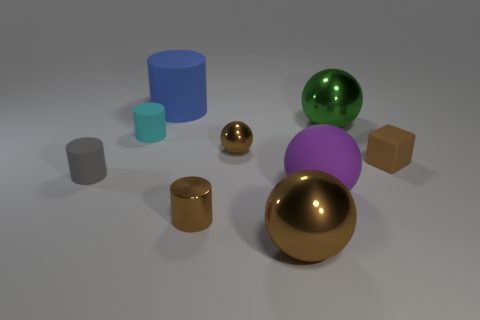There is a cyan thing that is the same size as the brown rubber object; what shape is it?
Your response must be concise. Cylinder. The other brown ball that is made of the same material as the small brown ball is what size?
Keep it short and to the point. Large. Do the green thing and the purple matte thing have the same shape?
Give a very brief answer. Yes. What is the color of the metallic cylinder that is the same size as the brown cube?
Ensure brevity in your answer.  Brown. There is a blue rubber object that is the same shape as the gray object; what is its size?
Provide a short and direct response. Large. There is a small metal object that is behind the rubber sphere; what shape is it?
Ensure brevity in your answer.  Sphere. Does the large purple rubber object have the same shape as the small thing left of the cyan matte thing?
Provide a succinct answer. No. Are there an equal number of tiny metal balls that are to the left of the gray thing and small matte cubes to the left of the big green metal thing?
Give a very brief answer. Yes. There is a small matte thing that is the same color as the tiny shiny sphere; what shape is it?
Provide a short and direct response. Cube. Does the big metallic object behind the purple rubber thing have the same color as the small cylinder behind the tiny brown rubber thing?
Your response must be concise. No. 